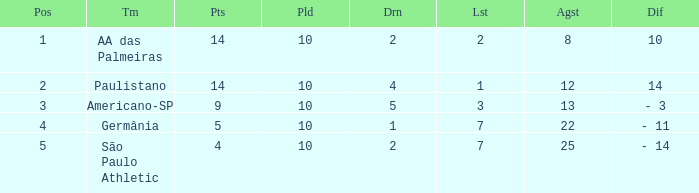What team has an against more than 8, lost of 7, and the position is 5? São Paulo Athletic. 